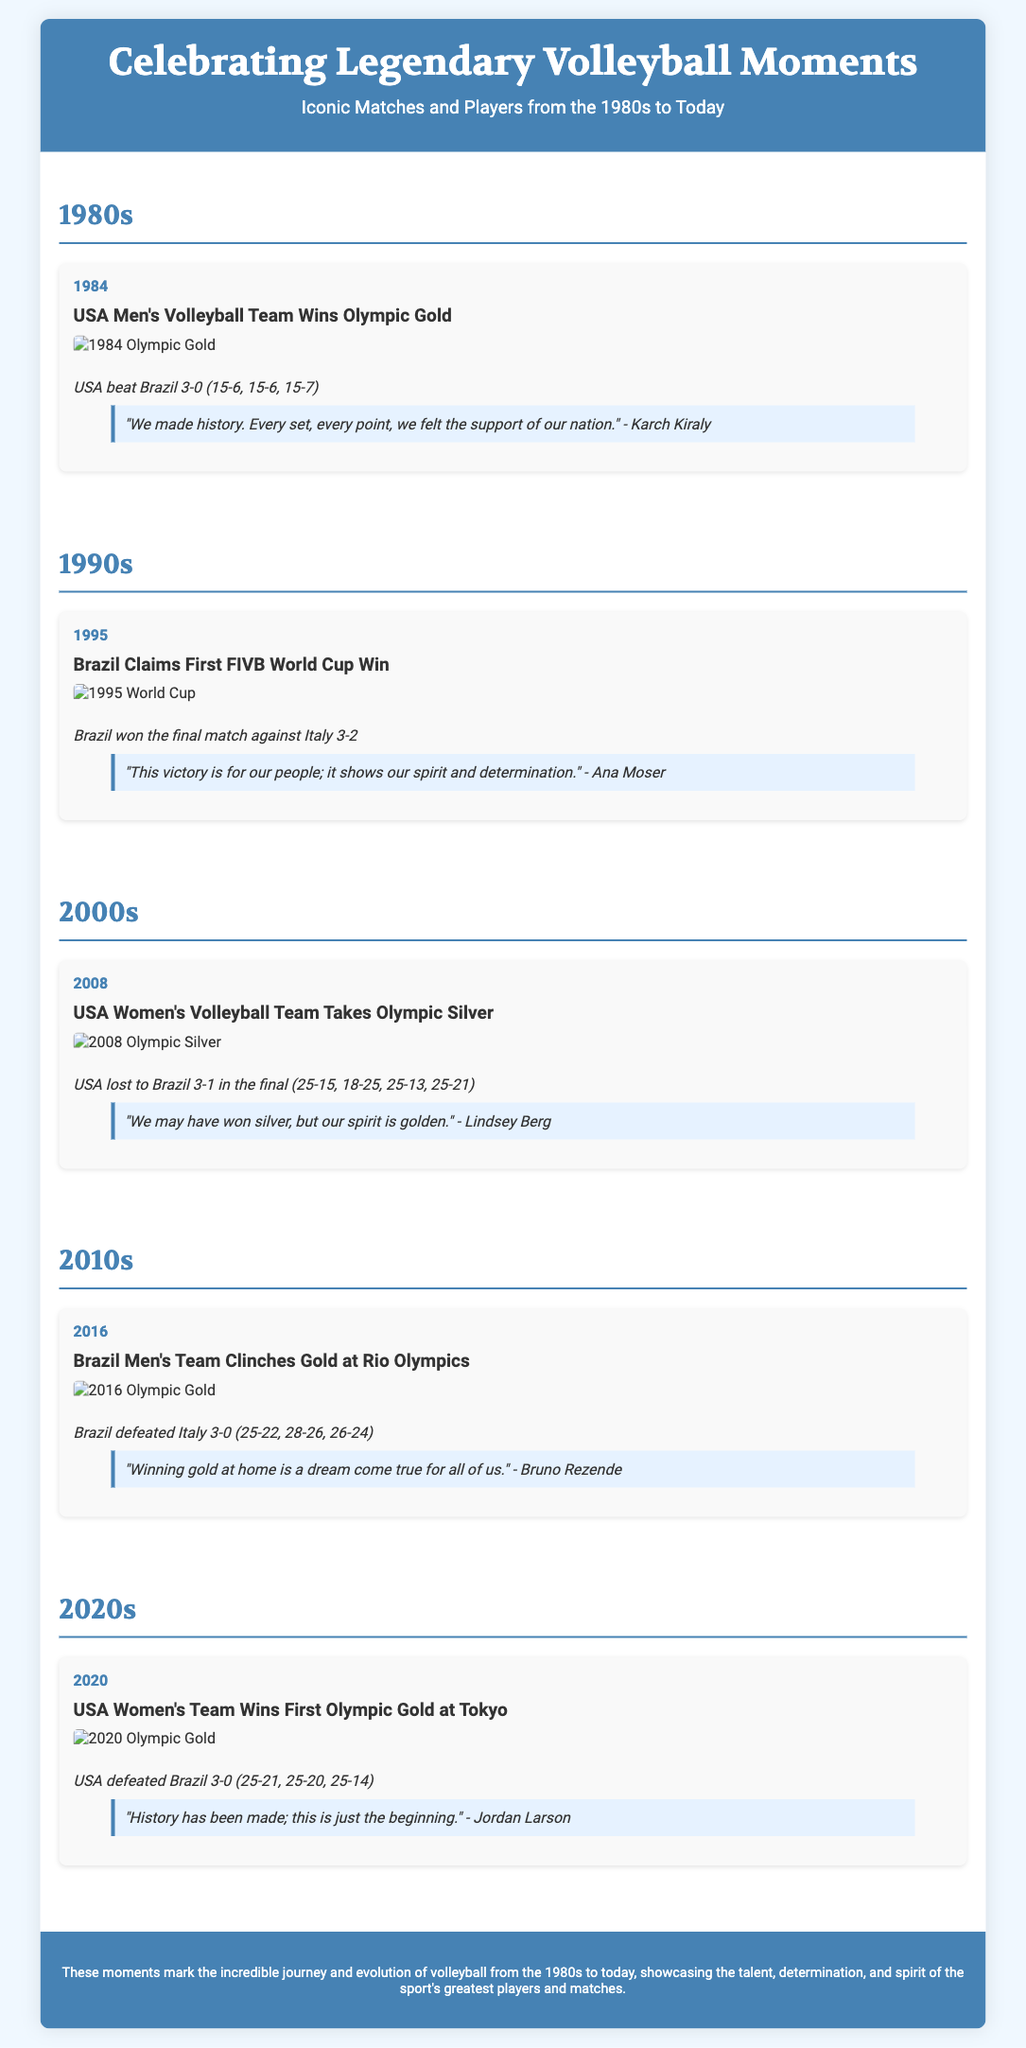What year did the USA Men's Volleyball Team win Olympic gold? The document states that the USA Men's Volleyball Team won Olympic gold in 1984.
Answer: 1984 Who won the first FIVB World Cup in 1995? According to the document, Brazil claimed their first FIVB World Cup win against Italy.
Answer: Brazil What quote is attributed to Karch Kiraly? The document includes a quote by Karch Kiraly that highlights the historical significance of the moment in 1984.
Answer: "We made history. Every set, every point, we felt the support of our nation." How many sets did the USA Women's Team lose in the 2008 Olympic final? The stats in the document indicate that the USA Women's Team lost to Brazil 3-1, meaning they lost one set.
Answer: 1 What is the first Olympic gold win for the USA Women's Team? The document mentions that the USA Women's Team won their first Olympic gold at Tokyo in 2020.
Answer: Tokyo Which player mentioned winning gold at home during the Rio Olympics? The document attributes the quote about winning gold at home to Bruno Rezende during the 2016 Olympics.
Answer: Bruno Rezende In which decade did Brazil defeat Italy 3-0 for the Olympic gold? The document states that Brazil defeated Italy 3-0 for the Olympic gold in 2016, which is in the 2010s decade.
Answer: 2010s What color medal did the USA Women's Volleyball Team win in 2008? The document clearly states the USA Women's Volleyball Team took home the silver medal in 2008.
Answer: Silver 